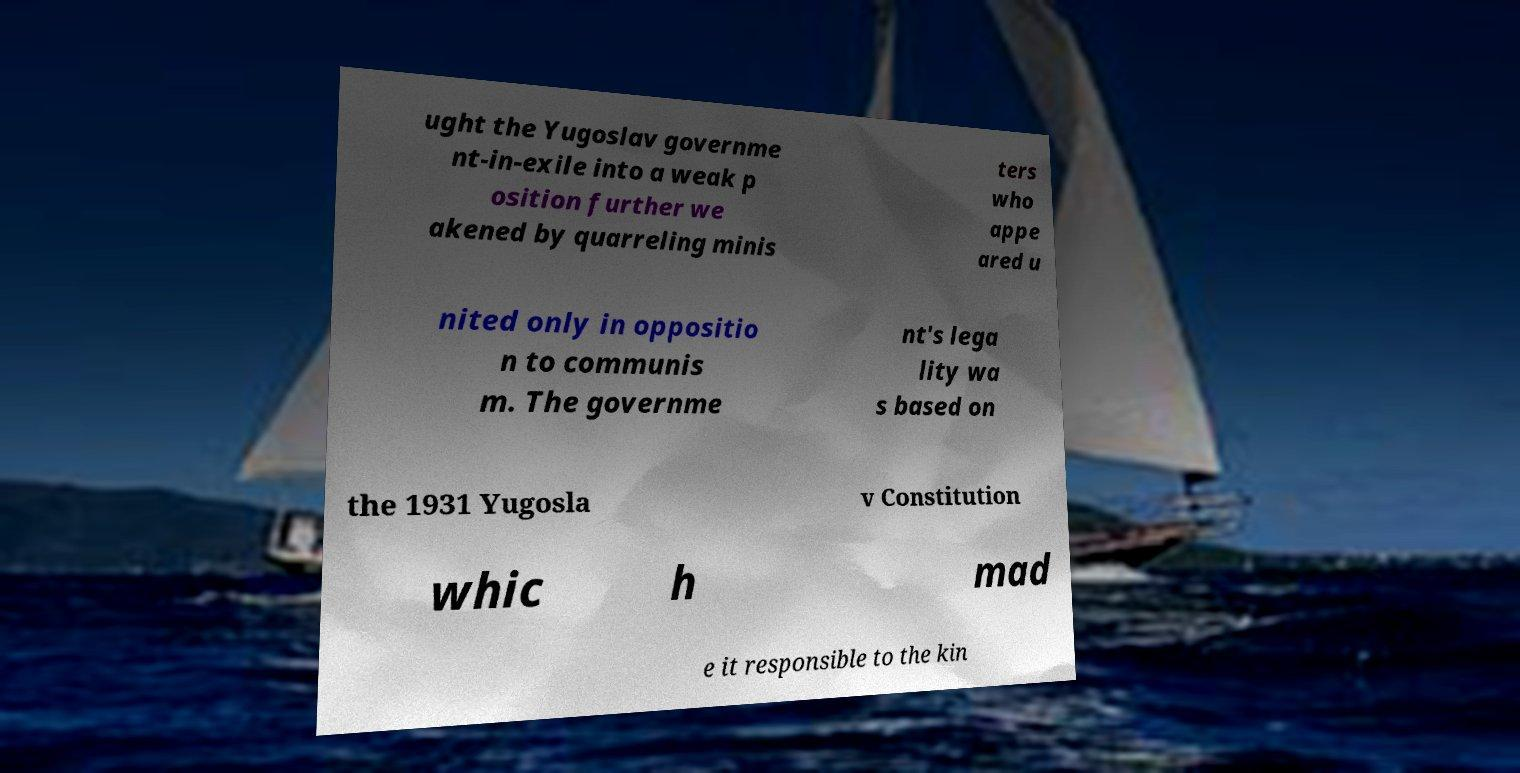Could you extract and type out the text from this image? ught the Yugoslav governme nt-in-exile into a weak p osition further we akened by quarreling minis ters who appe ared u nited only in oppositio n to communis m. The governme nt's lega lity wa s based on the 1931 Yugosla v Constitution whic h mad e it responsible to the kin 